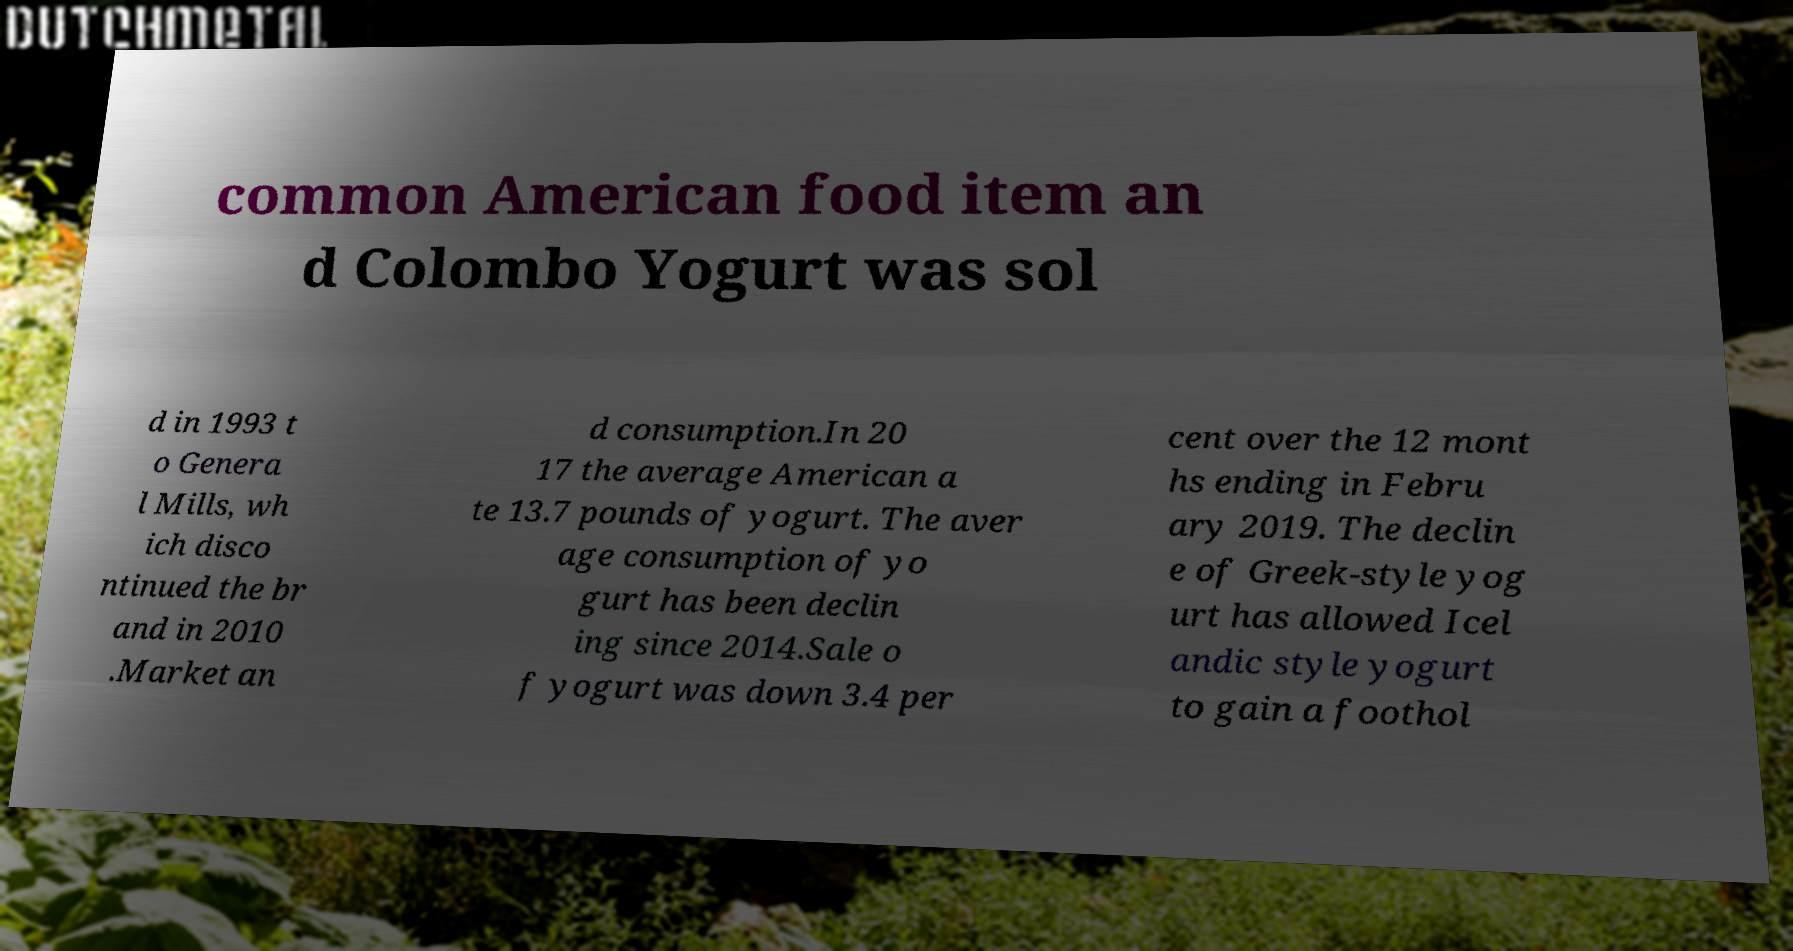For documentation purposes, I need the text within this image transcribed. Could you provide that? common American food item an d Colombo Yogurt was sol d in 1993 t o Genera l Mills, wh ich disco ntinued the br and in 2010 .Market an d consumption.In 20 17 the average American a te 13.7 pounds of yogurt. The aver age consumption of yo gurt has been declin ing since 2014.Sale o f yogurt was down 3.4 per cent over the 12 mont hs ending in Febru ary 2019. The declin e of Greek-style yog urt has allowed Icel andic style yogurt to gain a foothol 